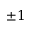Convert formula to latex. <formula><loc_0><loc_0><loc_500><loc_500>\pm 1</formula> 